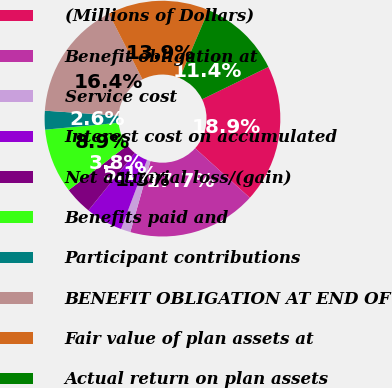Convert chart. <chart><loc_0><loc_0><loc_500><loc_500><pie_chart><fcel>(Millions of Dollars)<fcel>Benefit obligation at<fcel>Service cost<fcel>Interest cost on accumulated<fcel>Net actuarial loss/(gain)<fcel>Benefits paid and<fcel>Participant contributions<fcel>BENEFIT OBLIGATION AT END OF<fcel>Fair value of plan assets at<fcel>Actual return on plan assets<nl><fcel>18.94%<fcel>17.68%<fcel>1.32%<fcel>5.09%<fcel>3.83%<fcel>8.87%<fcel>2.57%<fcel>16.42%<fcel>13.9%<fcel>11.38%<nl></chart> 